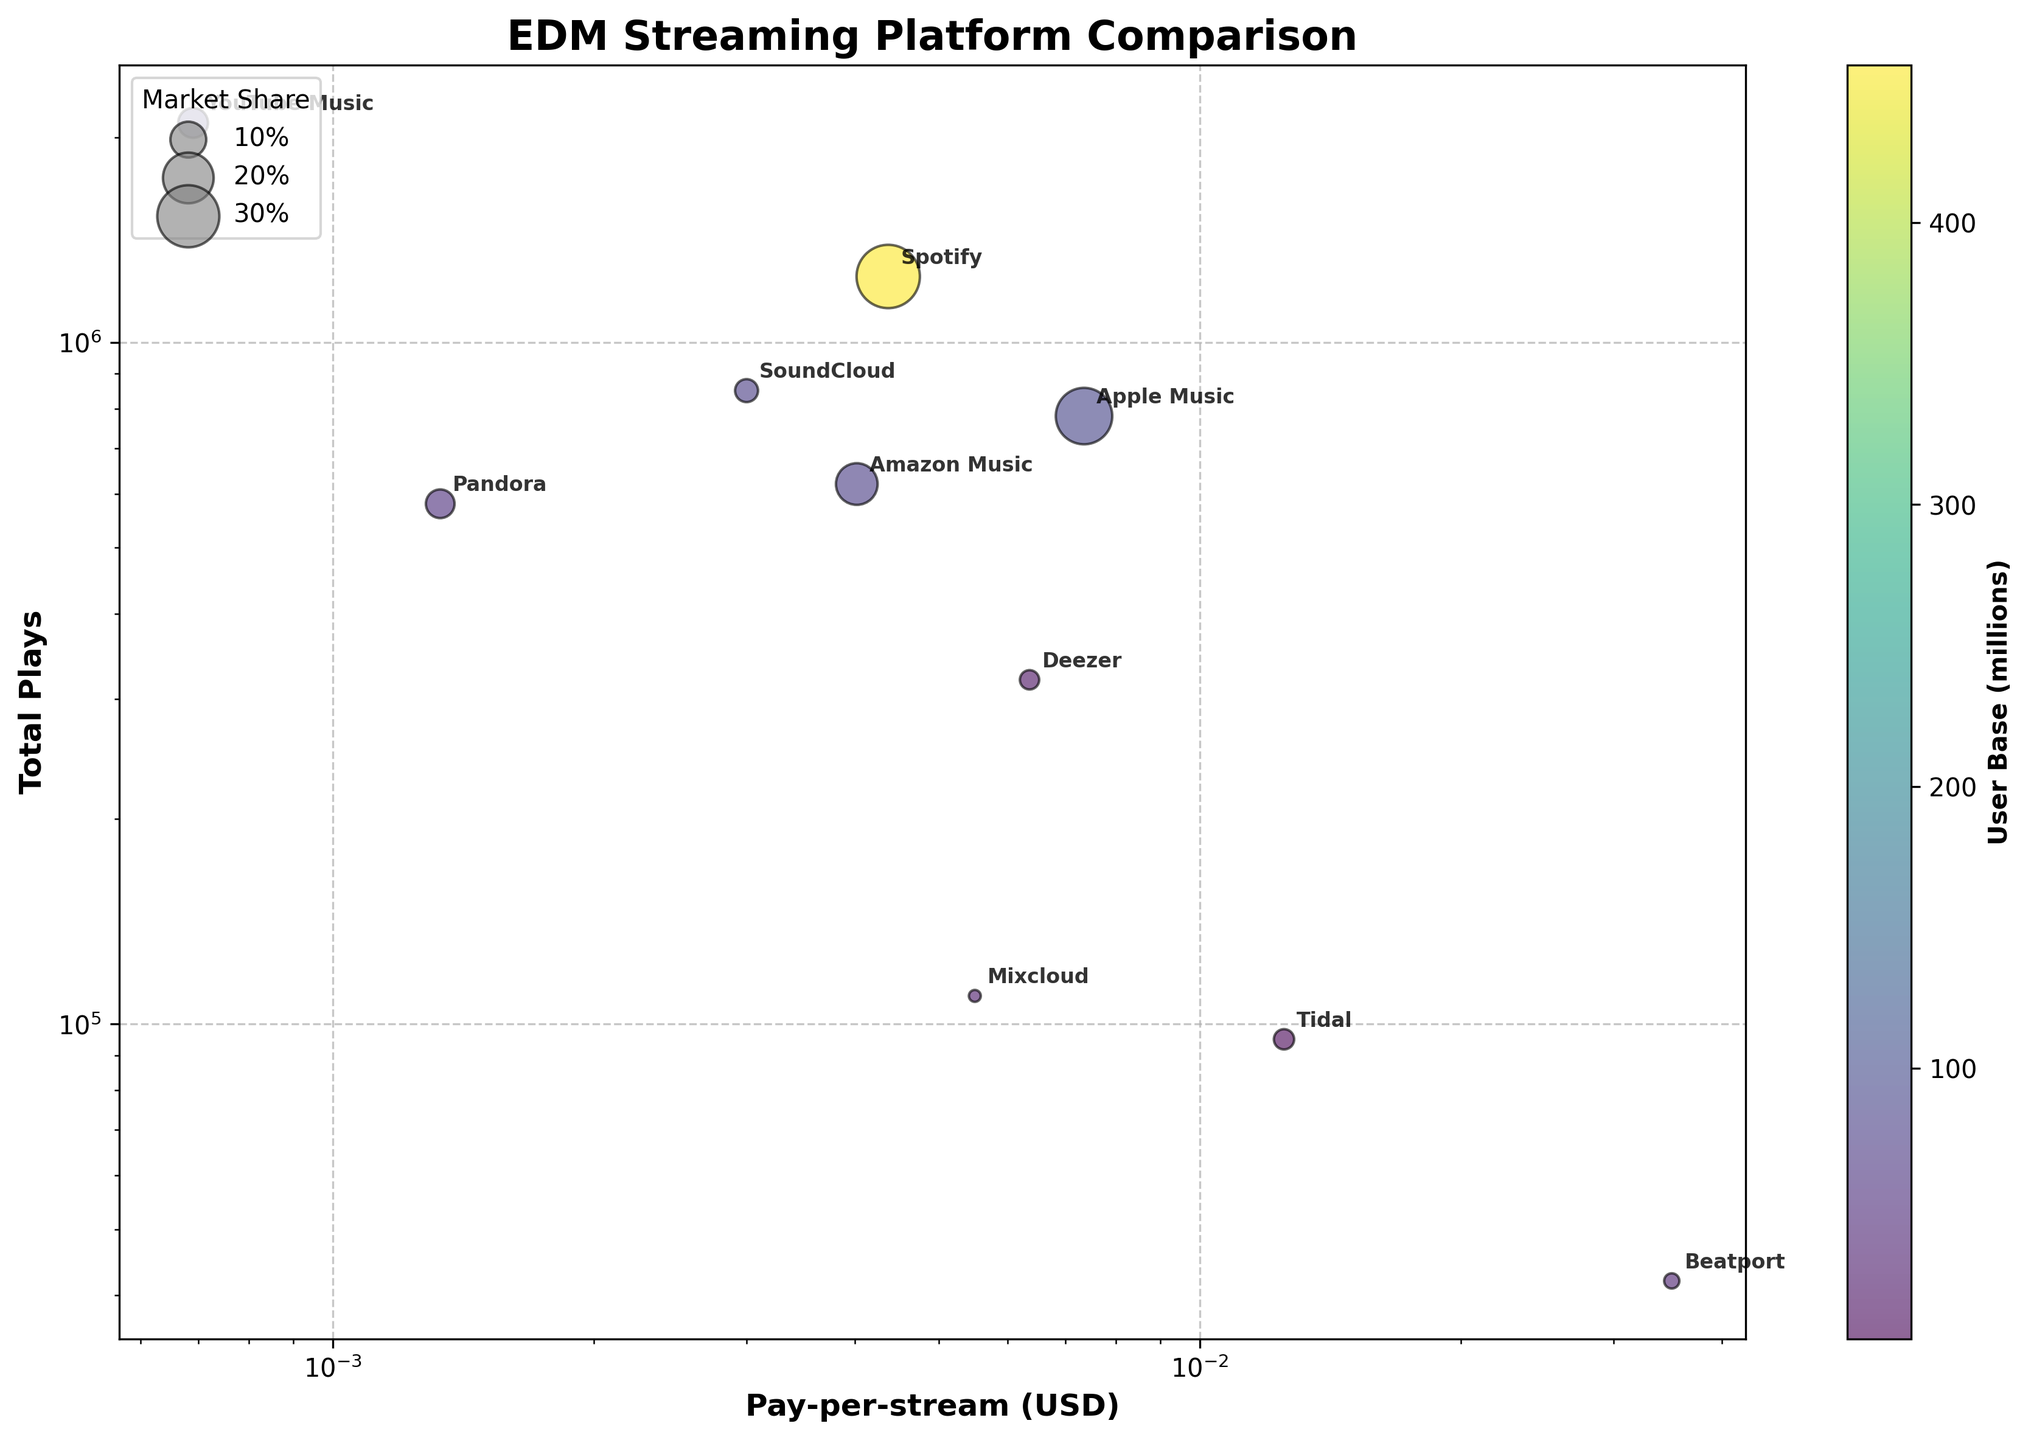Which platform has the highest pay-per-stream rate? The pay-per-stream rate is represented on the x-axis in the figure. The platform with the highest value along the x-axis is Tidal.
Answer: Tidal Which platform has the highest total plays? The total plays are represented on the y-axis in the figure. The platform with the highest value along the y-axis is YouTube Music.
Answer: YouTube Music How does the market share of Spotify compare to Beatport? Market share is represented by the size of the bubbles. The bubble for Spotify is significantly larger than the bubble for Beatport, indicating a higher market share.
Answer: Spotify has a higher market share What is the general relationship between pay-per-stream rate and total plays? Looking at the distribution of the points in the plot, platforms with higher pay-per-stream rates, like Tidal, have lower total plays, while platforms with lower pay-per-stream rates, like YouTube Music, have higher total plays. This suggests an inverse relationship.
Answer: Inverse relationship Which platform has a larger user base, Pandora or Deezer? The user base is indicated by the color of the bubbles, with a color scale provided to the right. Deezer's bubble has a lighter color compared to Pandora's bubble, indicating Deezer has a lower user base.
Answer: Pandora Which platform offers the best pay-per-stream rate for EDM tracks? The best pay-per-stream rate is the highest value on the x-axis. The highest pay-per-stream rate belongs to Beatport.
Answer: Beatport Compare the total plays between Apple Music and SoundCloud. The total plays is represented on the y-axis. Apple Music has approximately 780,000 total plays, while SoundCloud has around 850,000 total plays.
Answer: SoundCloud has more total plays What can you infer about YouTube Music’s pay-per-stream rate and user base? YouTube Music has a low pay-per-stream rate (near the left side of the x-axis) but a high user base (indicated by the dark color of its bubble).
Answer: Low pay-per-stream rate, high user base Which platform is closest in total plays to Amazon Music? On the y-axis, looking at the platform closest to Amazon Music's total plays (620,000), Pandora appears to be the closest with around 580,000 total plays.
Answer: Pandora 